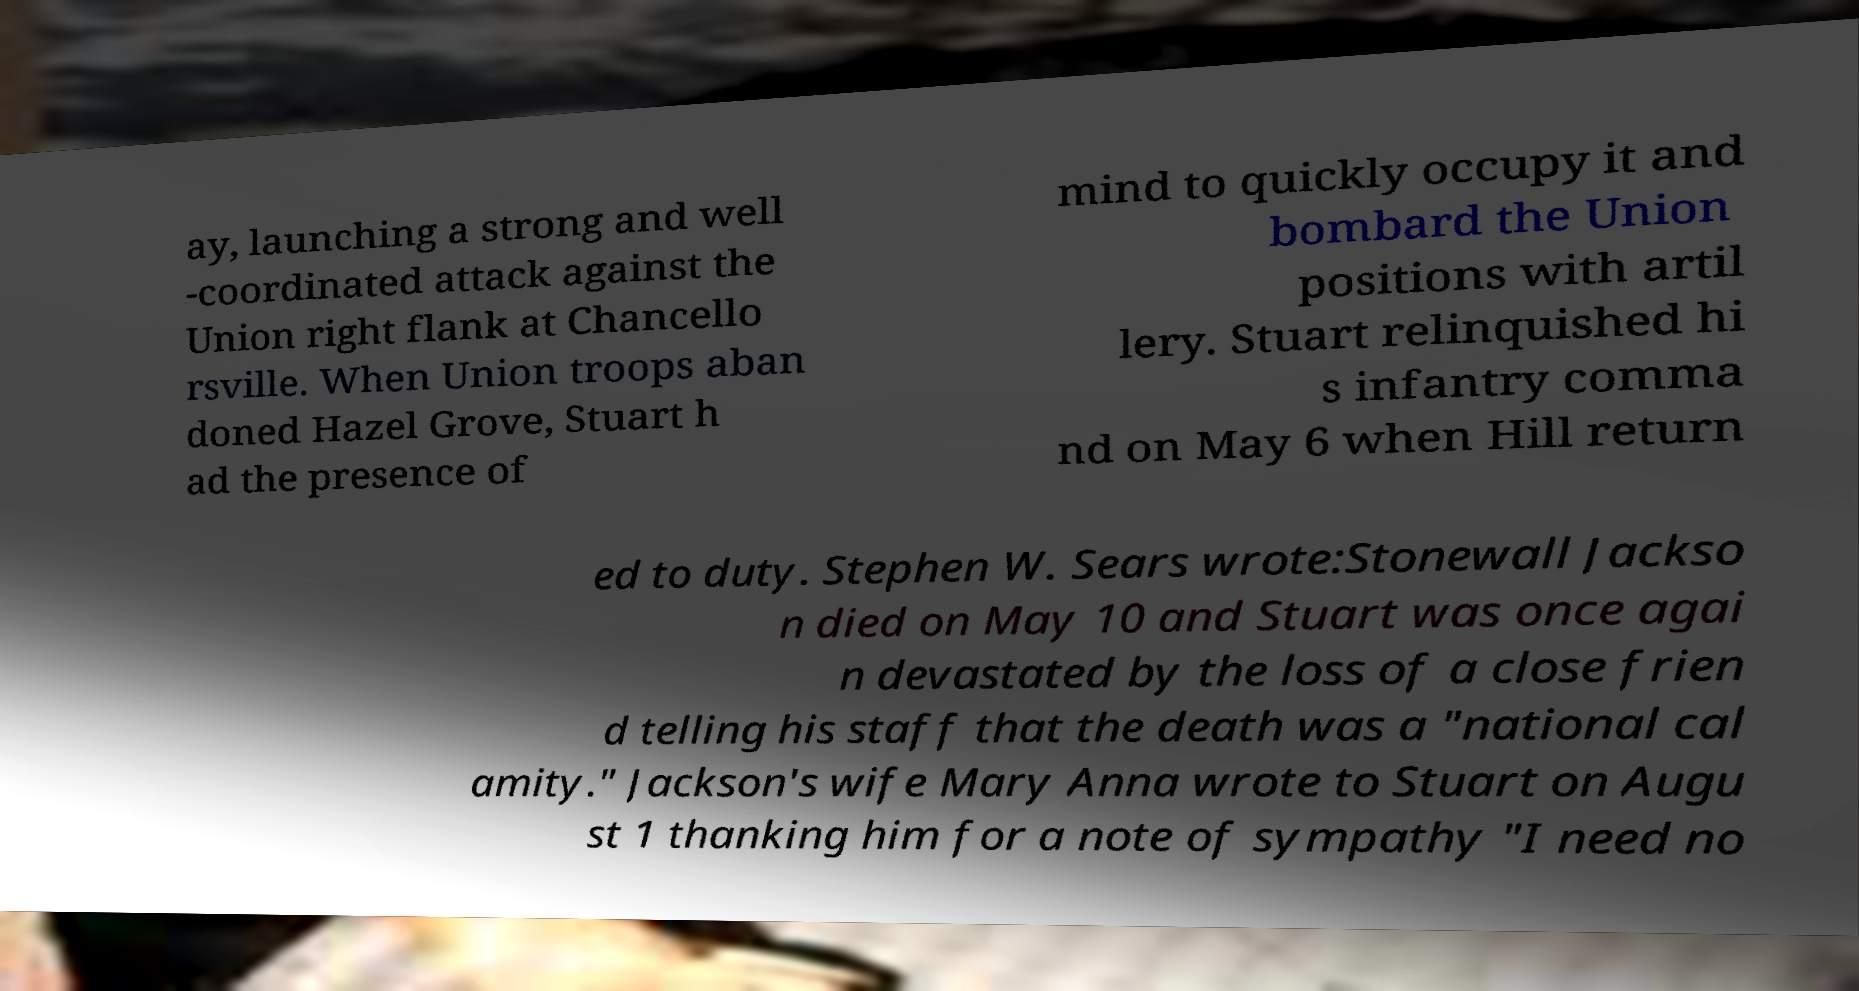There's text embedded in this image that I need extracted. Can you transcribe it verbatim? ay, launching a strong and well -coordinated attack against the Union right flank at Chancello rsville. When Union troops aban doned Hazel Grove, Stuart h ad the presence of mind to quickly occupy it and bombard the Union positions with artil lery. Stuart relinquished hi s infantry comma nd on May 6 when Hill return ed to duty. Stephen W. Sears wrote:Stonewall Jackso n died on May 10 and Stuart was once agai n devastated by the loss of a close frien d telling his staff that the death was a "national cal amity." Jackson's wife Mary Anna wrote to Stuart on Augu st 1 thanking him for a note of sympathy "I need no 